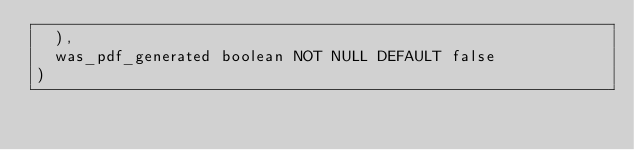Convert code to text. <code><loc_0><loc_0><loc_500><loc_500><_SQL_>	),
	was_pdf_generated boolean NOT NULL DEFAULT false
)
</code> 